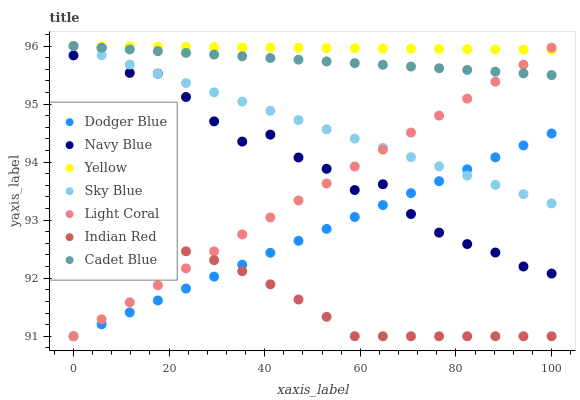Does Indian Red have the minimum area under the curve?
Answer yes or no. Yes. Does Yellow have the maximum area under the curve?
Answer yes or no. Yes. Does Navy Blue have the minimum area under the curve?
Answer yes or no. No. Does Navy Blue have the maximum area under the curve?
Answer yes or no. No. Is Dodger Blue the smoothest?
Answer yes or no. Yes. Is Navy Blue the roughest?
Answer yes or no. Yes. Is Yellow the smoothest?
Answer yes or no. No. Is Yellow the roughest?
Answer yes or no. No. Does Light Coral have the lowest value?
Answer yes or no. Yes. Does Navy Blue have the lowest value?
Answer yes or no. No. Does Sky Blue have the highest value?
Answer yes or no. Yes. Does Navy Blue have the highest value?
Answer yes or no. No. Is Dodger Blue less than Cadet Blue?
Answer yes or no. Yes. Is Sky Blue greater than Indian Red?
Answer yes or no. Yes. Does Cadet Blue intersect Navy Blue?
Answer yes or no. Yes. Is Cadet Blue less than Navy Blue?
Answer yes or no. No. Is Cadet Blue greater than Navy Blue?
Answer yes or no. No. Does Dodger Blue intersect Cadet Blue?
Answer yes or no. No. 